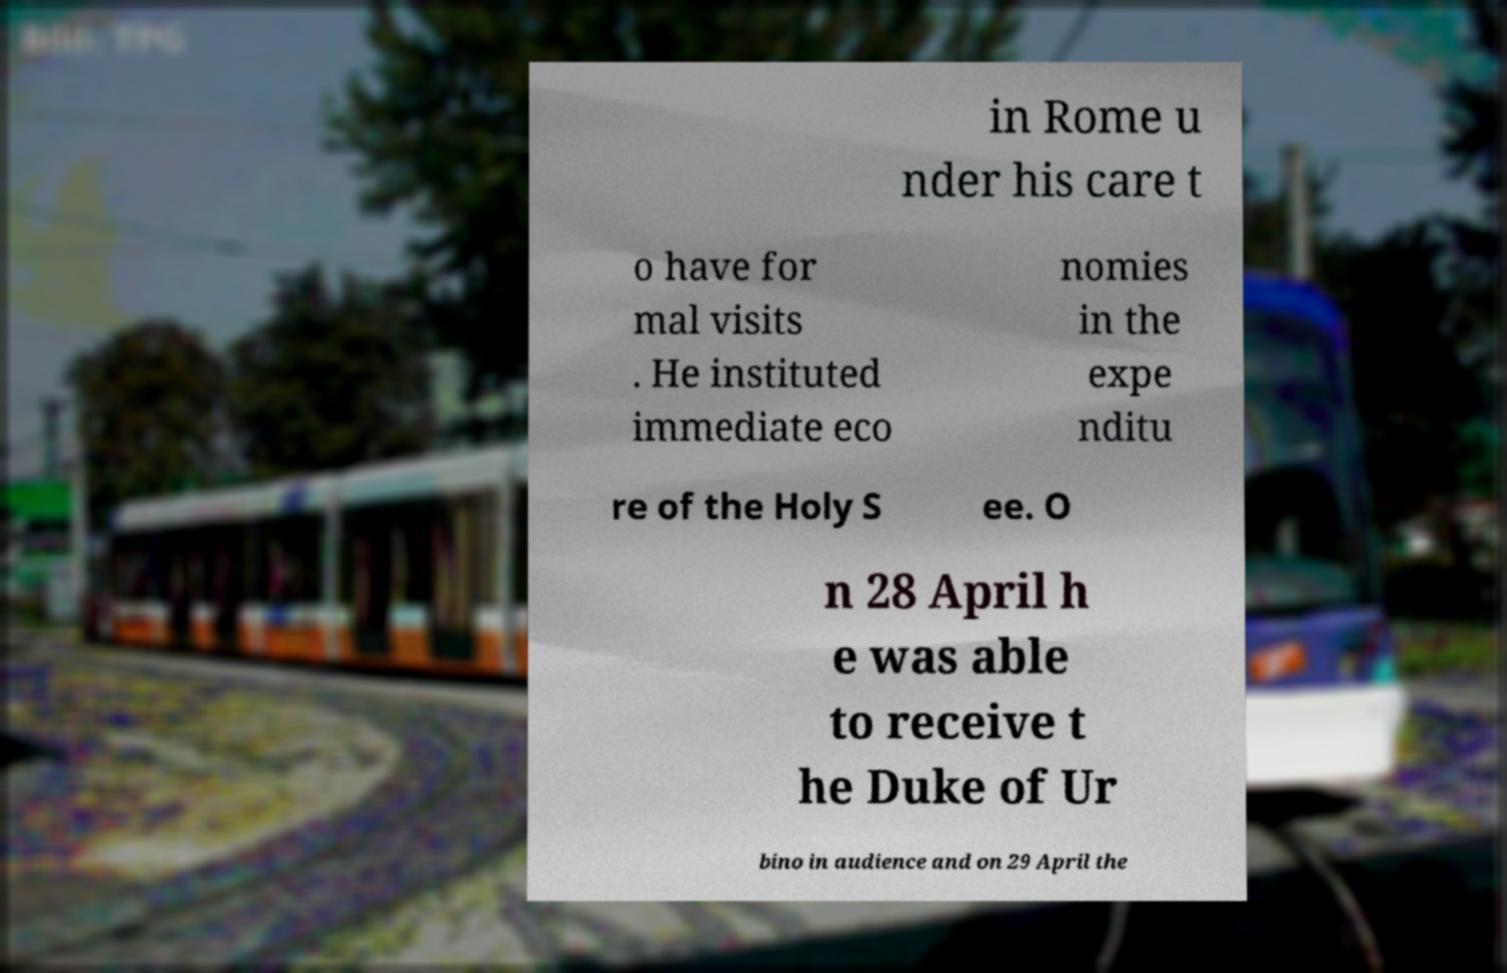Please read and relay the text visible in this image. What does it say? in Rome u nder his care t o have for mal visits . He instituted immediate eco nomies in the expe nditu re of the Holy S ee. O n 28 April h e was able to receive t he Duke of Ur bino in audience and on 29 April the 